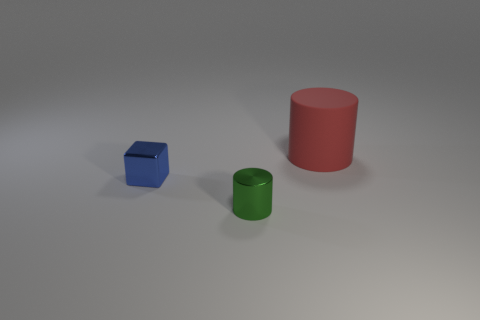Add 3 tiny cubes. How many objects exist? 6 Subtract all cylinders. How many objects are left? 1 Subtract all large brown cubes. Subtract all tiny cylinders. How many objects are left? 2 Add 1 big red rubber cylinders. How many big red rubber cylinders are left? 2 Add 1 small yellow shiny things. How many small yellow shiny things exist? 1 Subtract 0 purple cylinders. How many objects are left? 3 